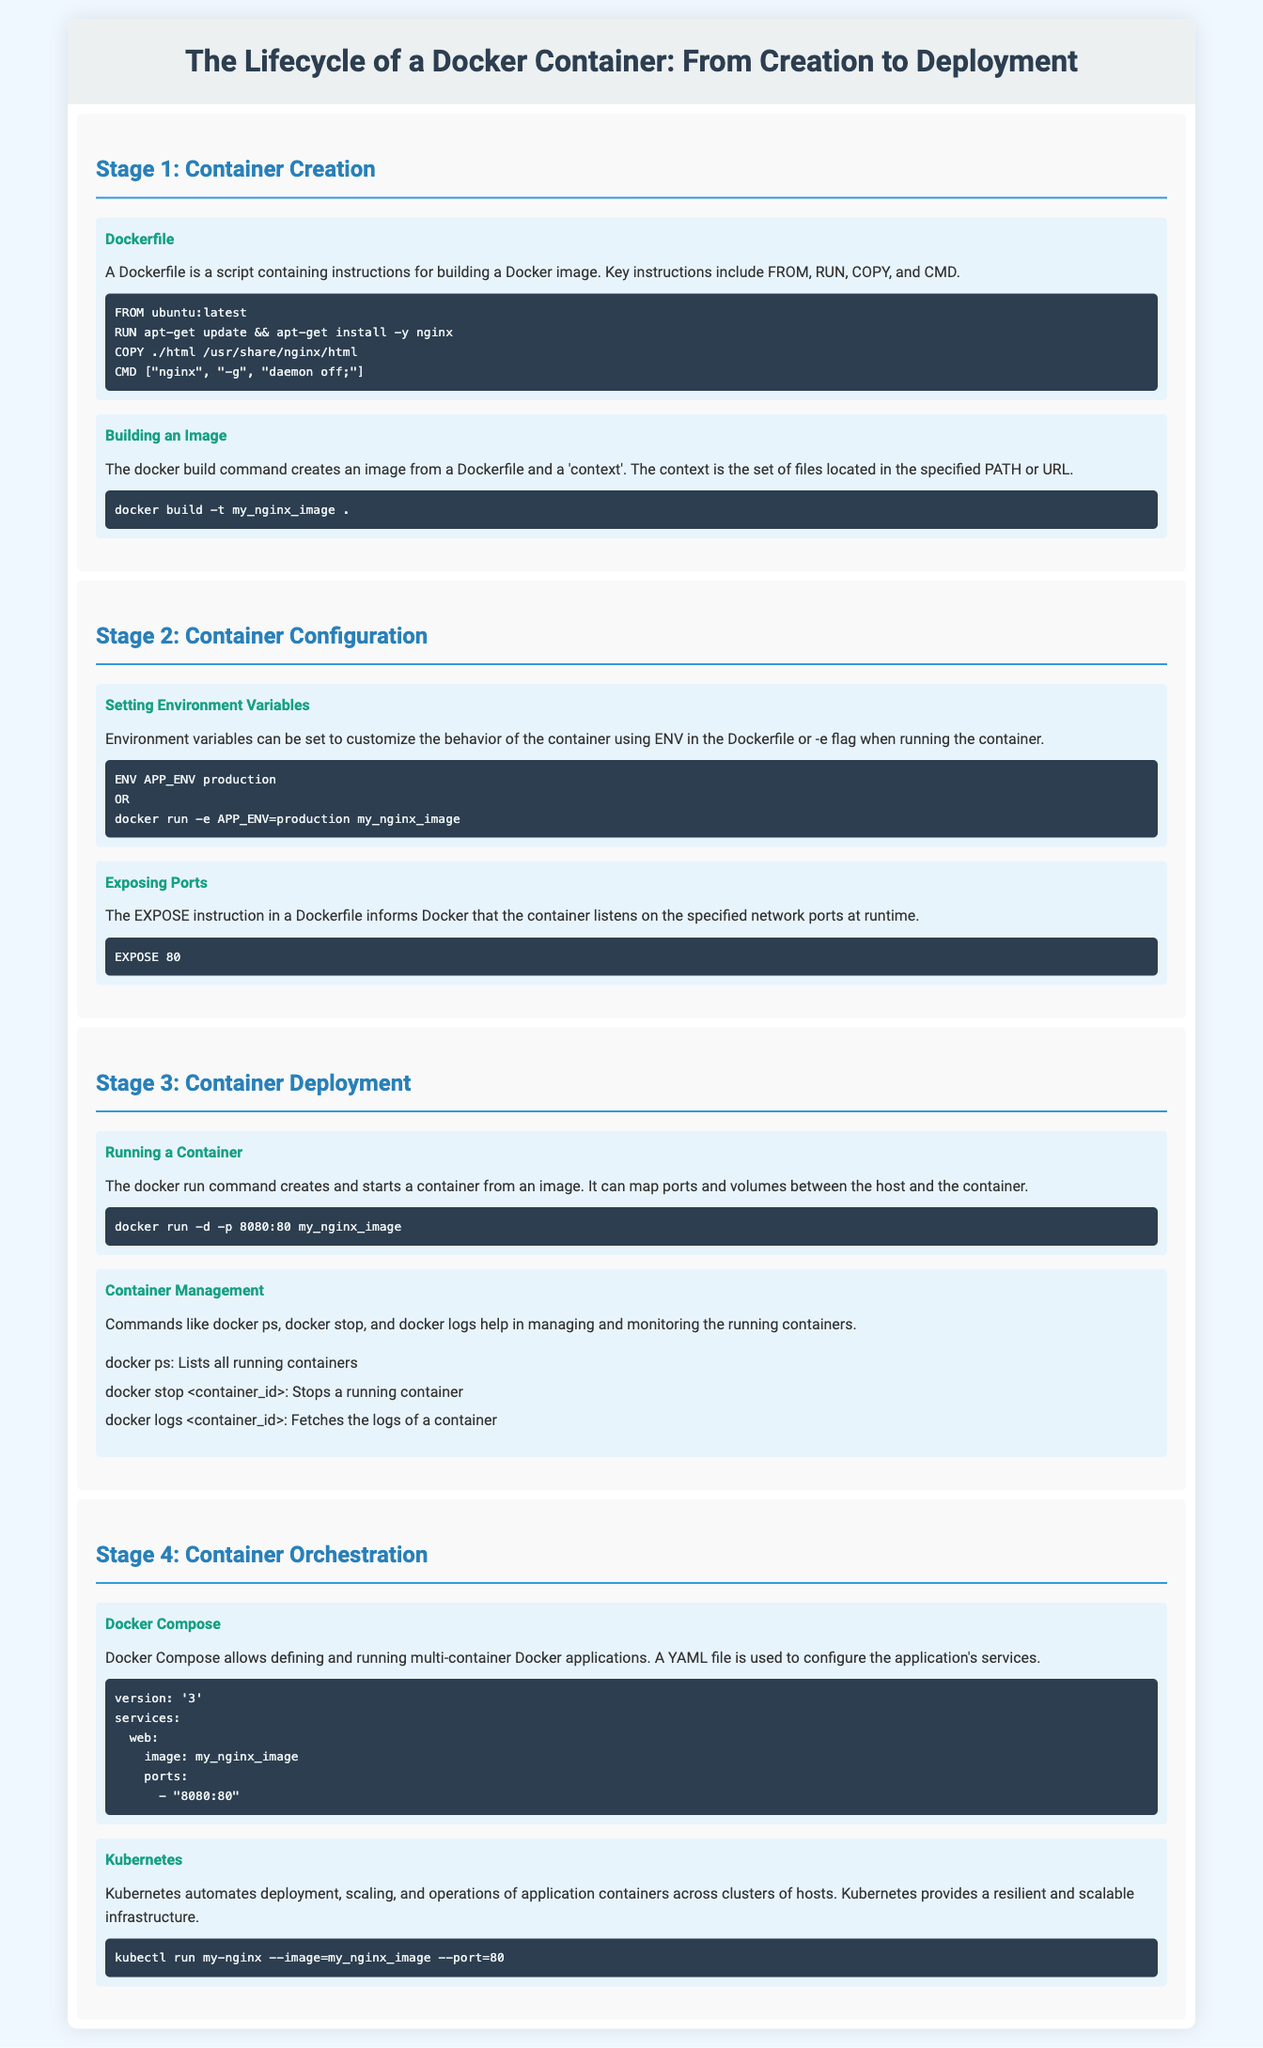What is the title of the infographic? The title is stated at the top of the document and refers to the Docker container lifecycle.
Answer: The Lifecycle of a Docker Container: From Creation to Deployment What is the first stage of the Docker container lifecycle? The stages are numbered and labeled in the document, with the first stage clearly defined.
Answer: Container Creation What instruction is used to create a Docker image? The document explains various instructions, and one specific instruction is highlighted for creating Docker images in the first stage.
Answer: Dockerfile Which command is used to run a container? The command for running a container is presented in the section discussing container deployment.
Answer: docker run What network port is exposed in the example? The EXPOSE instruction in the document specifies which port the container listens on during runtime.
Answer: 80 What orchestration tool is mentioned for automated deployment? The document lists tools and solutions for container orchestration, specifically naming one popular tool in the last stage.
Answer: Kubernetes How are multi-container applications defined in Docker? The document describes a method for defining multi-container applications, which is a specific functionality of Docker.
Answer: Docker Compose How many management commands are listed for container management? The document includes a list of commands under container management, allowing for easy retrieval of this information.
Answer: Three What is the example application image name provided in the Docker Compose section? The image name for the example application is explicitly mentioned in the YAML file example of Docker Compose.
Answer: my_nginx_image 